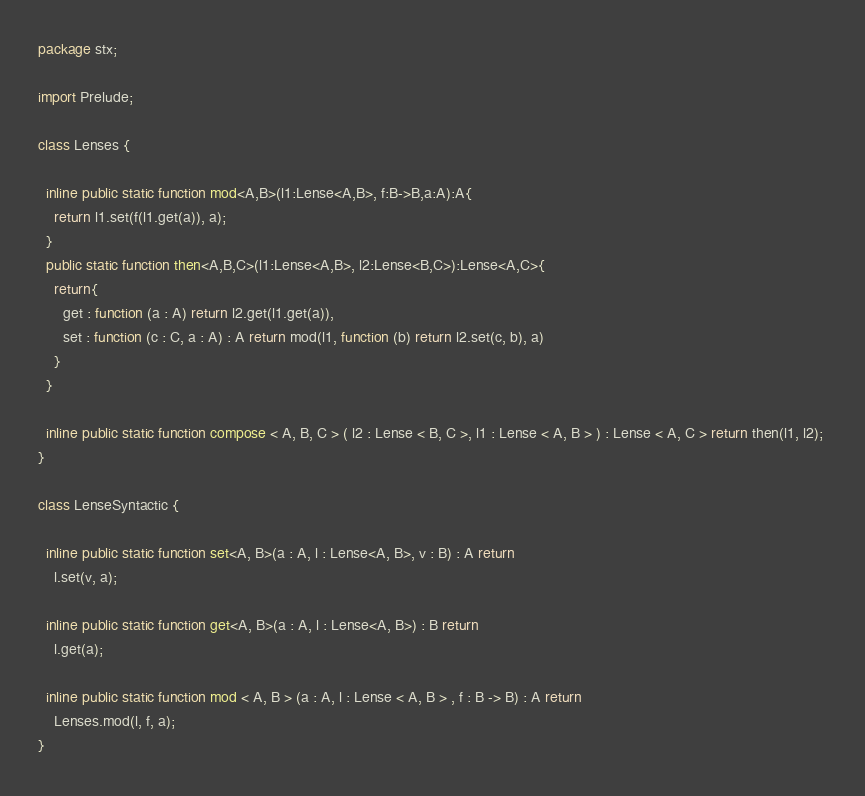Convert code to text. <code><loc_0><loc_0><loc_500><loc_500><_Haxe_>package stx;

import Prelude;

class Lenses {

  inline public static function mod<A,B>(l1:Lense<A,B>, f:B->B,a:A):A{
    return l1.set(f(l1.get(a)), a);
  }  
  public static function then<A,B,C>(l1:Lense<A,B>, l2:Lense<B,C>):Lense<A,C>{
    return{
      get : function (a : A) return l2.get(l1.get(a)),
      set : function (c : C, a : A) : A return mod(l1, function (b) return l2.set(c, b), a)
    }
  }
  
  inline public static function compose < A, B, C > ( l2 : Lense < B, C >, l1 : Lense < A, B > ) : Lense < A, C > return then(l1, l2); 
}

class LenseSyntactic {
  
  inline public static function set<A, B>(a : A, l : Lense<A, B>, v : B) : A return
    l.set(v, a);

  inline public static function get<A, B>(a : A, l : Lense<A, B>) : B return
    l.get(a);
   
  inline public static function mod < A, B > (a : A, l : Lense < A, B > , f : B -> B) : A return
    Lenses.mod(l, f, a);
}</code> 